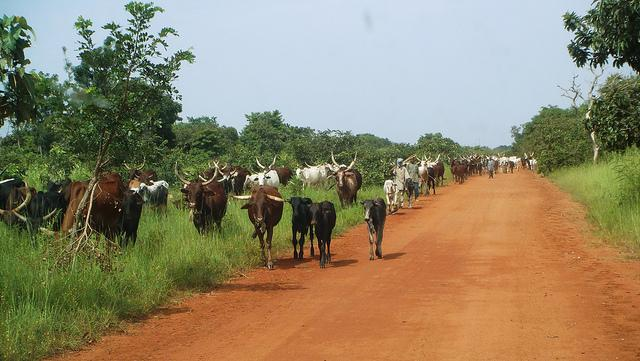What do many of these animals have? horns 